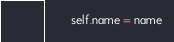Convert code to text. <code><loc_0><loc_0><loc_500><loc_500><_Python_>        self.name = name
</code> 